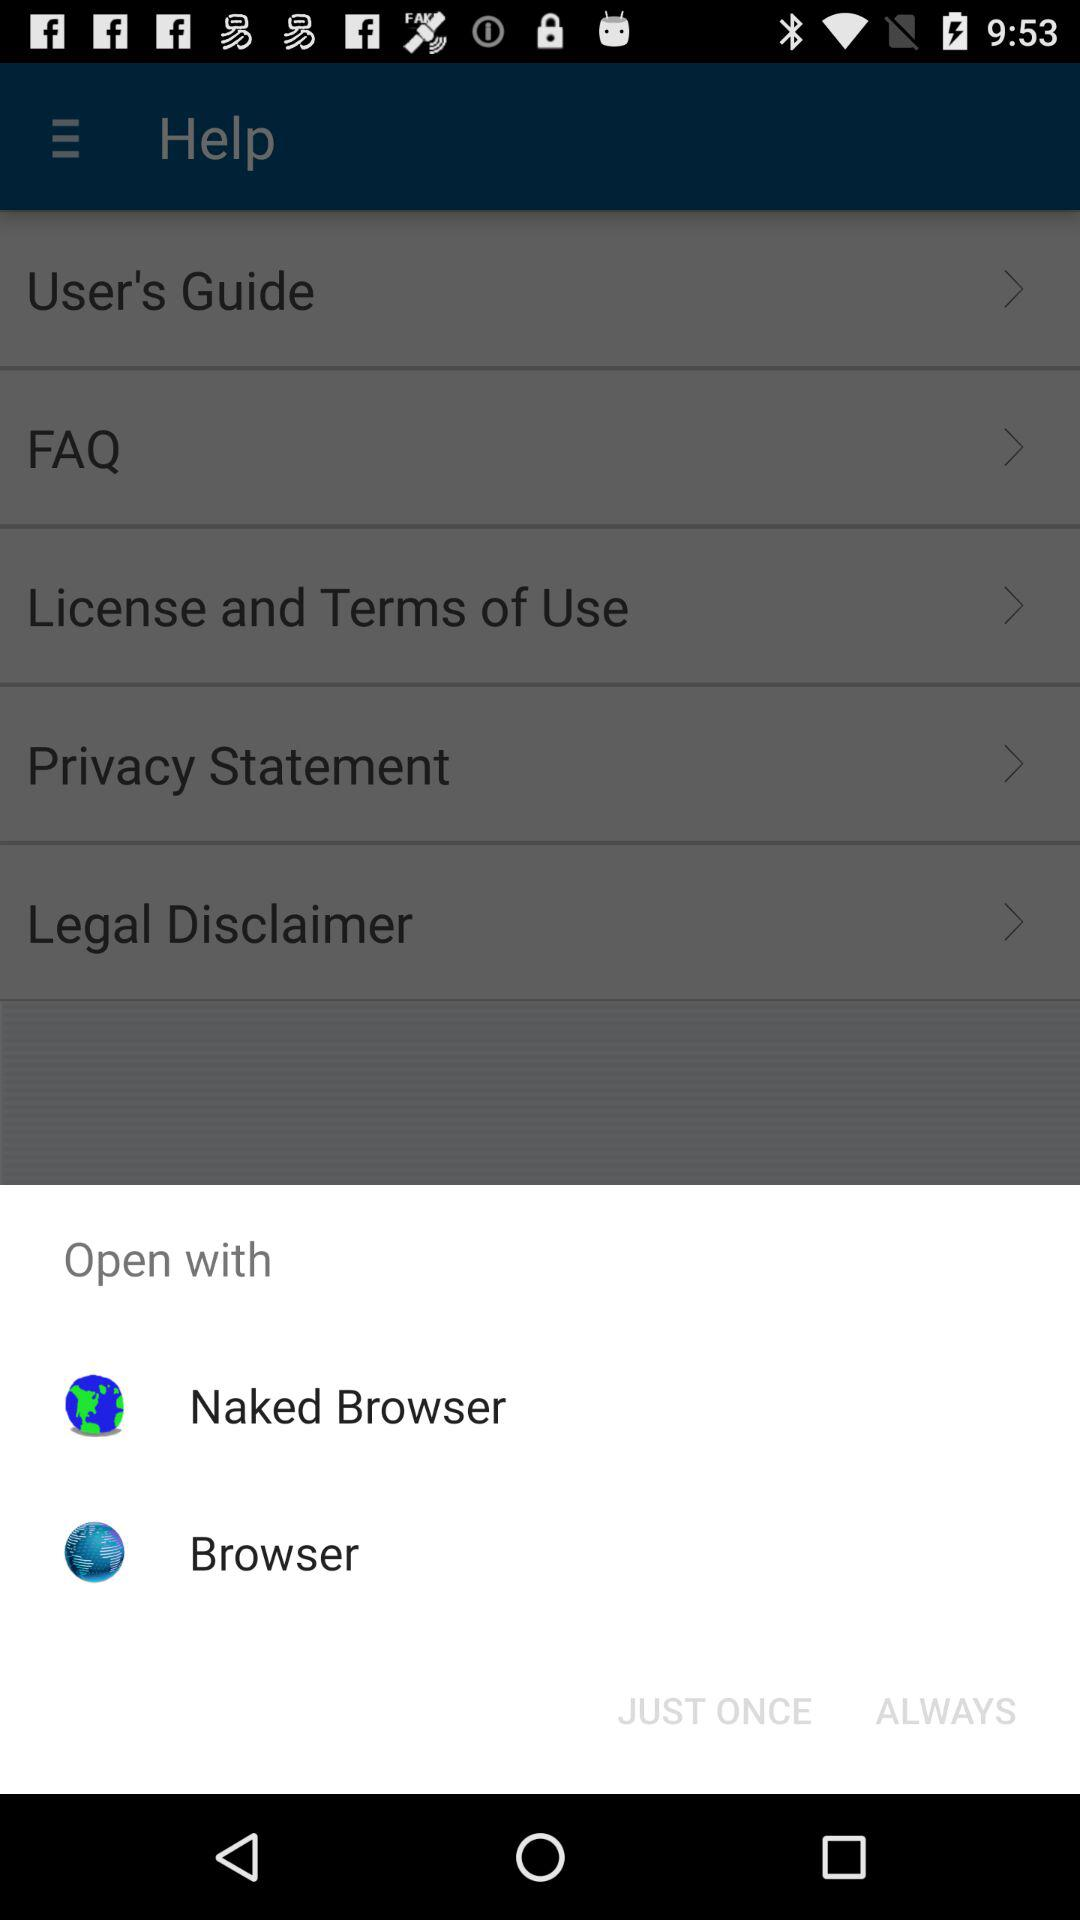Which application can we use to open it? You can use "Naked Browser" and "Browser". 